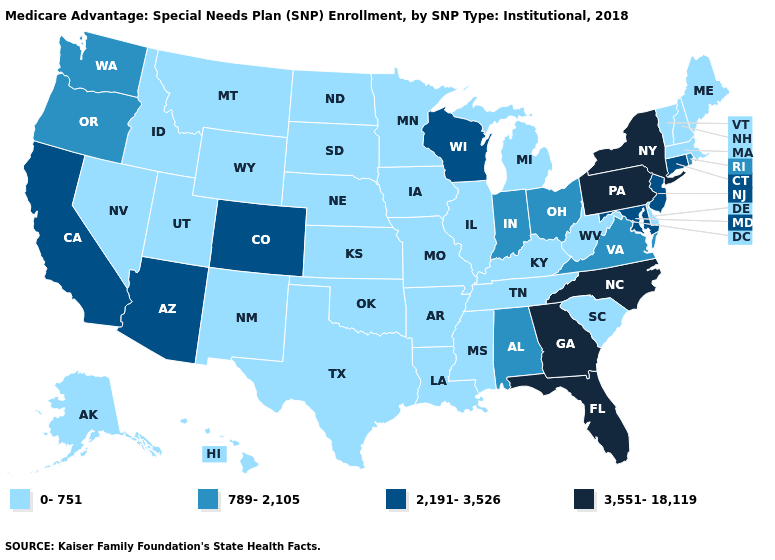Name the states that have a value in the range 0-751?
Answer briefly. Alaska, Arkansas, Delaware, Hawaii, Idaho, Illinois, Iowa, Kansas, Kentucky, Louisiana, Maine, Massachusetts, Michigan, Minnesota, Mississippi, Missouri, Montana, Nebraska, Nevada, New Hampshire, New Mexico, North Dakota, Oklahoma, South Carolina, South Dakota, Tennessee, Texas, Utah, Vermont, West Virginia, Wyoming. What is the lowest value in the Northeast?
Answer briefly. 0-751. Does the first symbol in the legend represent the smallest category?
Concise answer only. Yes. Does Mississippi have the lowest value in the South?
Be succinct. Yes. Does Wyoming have a lower value than South Carolina?
Answer briefly. No. Does Kansas have a higher value than South Carolina?
Write a very short answer. No. Among the states that border Kentucky , does Ohio have the highest value?
Answer briefly. Yes. What is the highest value in the Northeast ?
Be succinct. 3,551-18,119. Name the states that have a value in the range 789-2,105?
Quick response, please. Alabama, Indiana, Ohio, Oregon, Rhode Island, Virginia, Washington. Which states have the lowest value in the USA?
Keep it brief. Alaska, Arkansas, Delaware, Hawaii, Idaho, Illinois, Iowa, Kansas, Kentucky, Louisiana, Maine, Massachusetts, Michigan, Minnesota, Mississippi, Missouri, Montana, Nebraska, Nevada, New Hampshire, New Mexico, North Dakota, Oklahoma, South Carolina, South Dakota, Tennessee, Texas, Utah, Vermont, West Virginia, Wyoming. Does Colorado have the lowest value in the USA?
Keep it brief. No. Among the states that border Missouri , which have the lowest value?
Quick response, please. Arkansas, Illinois, Iowa, Kansas, Kentucky, Nebraska, Oklahoma, Tennessee. Does New Jersey have the highest value in the USA?
Answer briefly. No. Name the states that have a value in the range 3,551-18,119?
Answer briefly. Florida, Georgia, New York, North Carolina, Pennsylvania. 